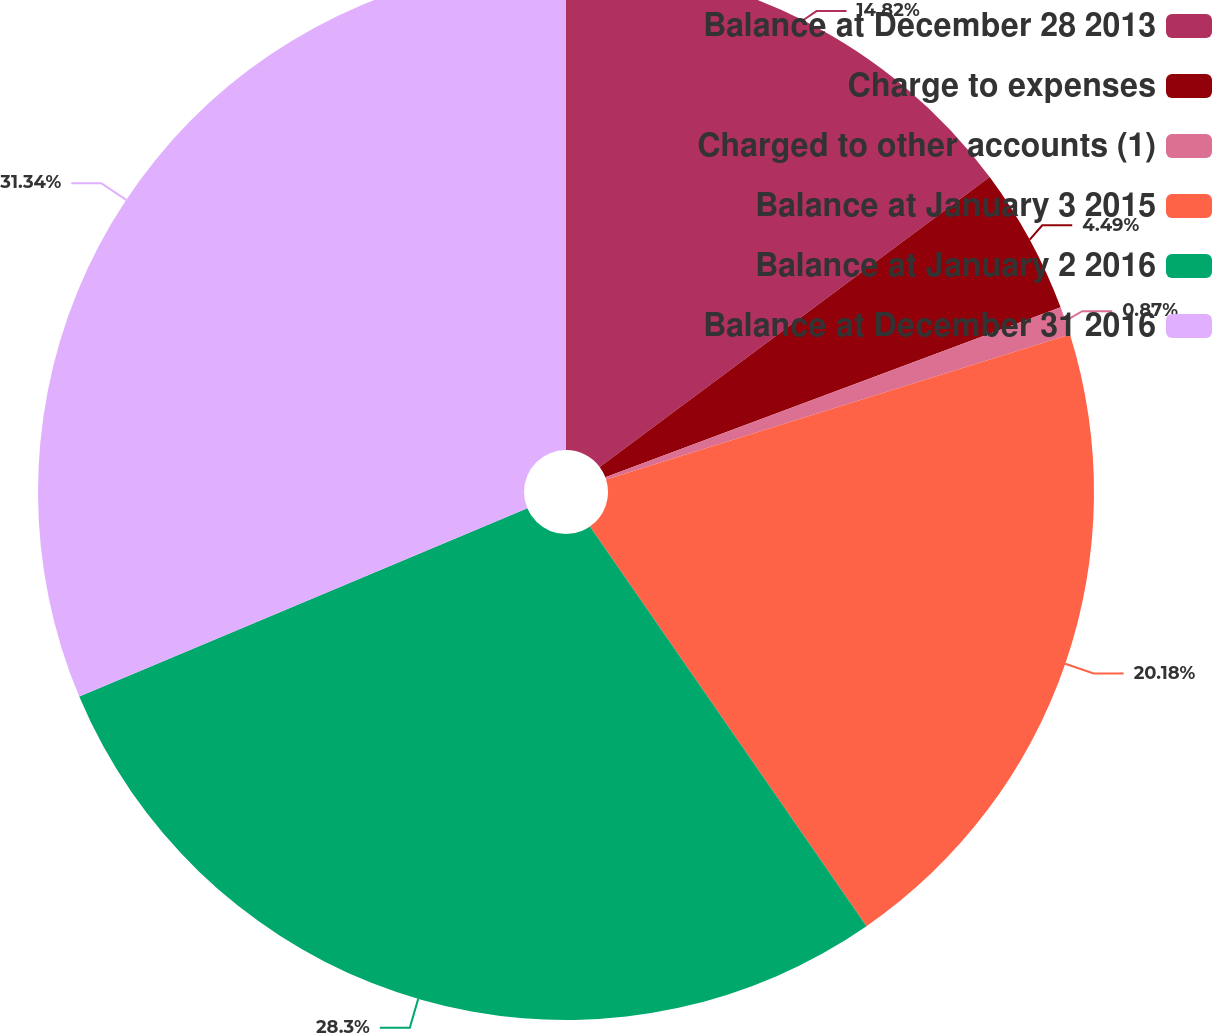Convert chart. <chart><loc_0><loc_0><loc_500><loc_500><pie_chart><fcel>Balance at December 28 2013<fcel>Charge to expenses<fcel>Charged to other accounts (1)<fcel>Balance at January 3 2015<fcel>Balance at January 2 2016<fcel>Balance at December 31 2016<nl><fcel>14.82%<fcel>4.49%<fcel>0.87%<fcel>20.18%<fcel>28.3%<fcel>31.33%<nl></chart> 